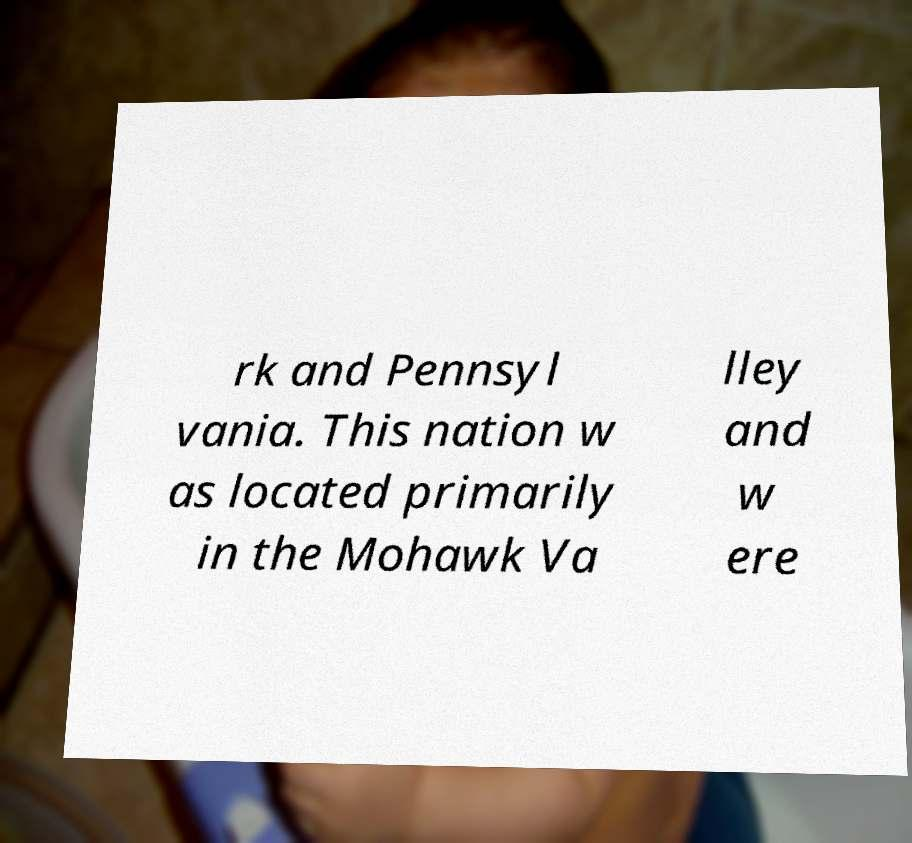For documentation purposes, I need the text within this image transcribed. Could you provide that? rk and Pennsyl vania. This nation w as located primarily in the Mohawk Va lley and w ere 